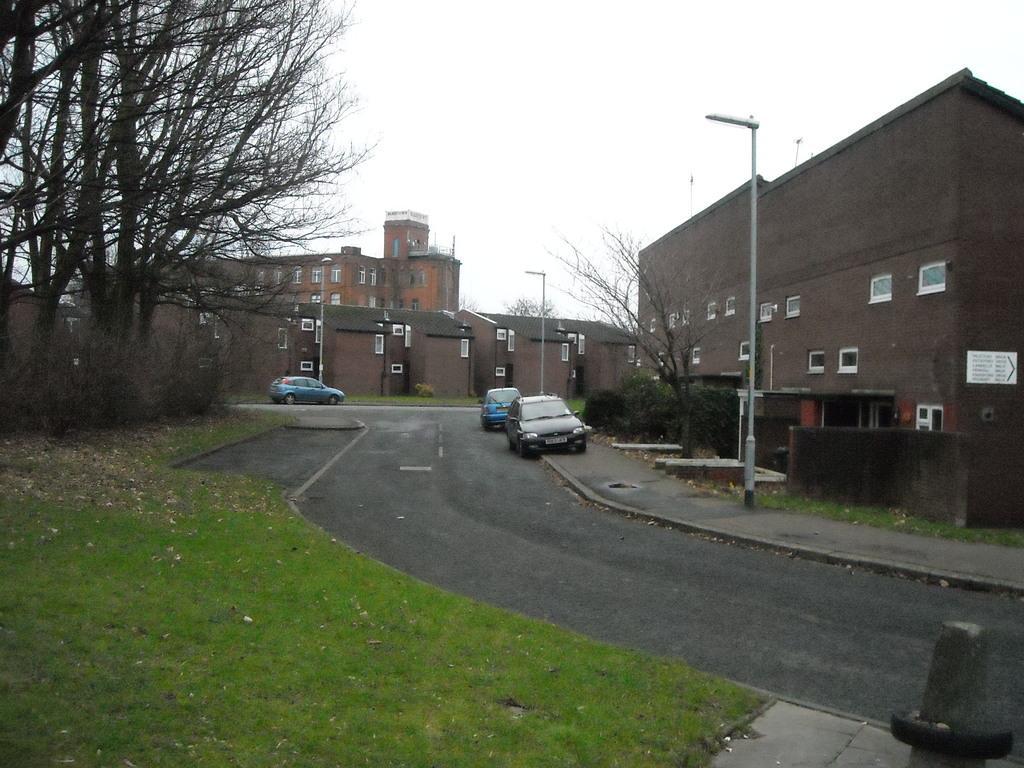Please provide a concise description of this image. In this image I see number of buildings, poles, trees, bushes and the green grass and I see the road and I see 3 cars. In the background I see the clear sky. 